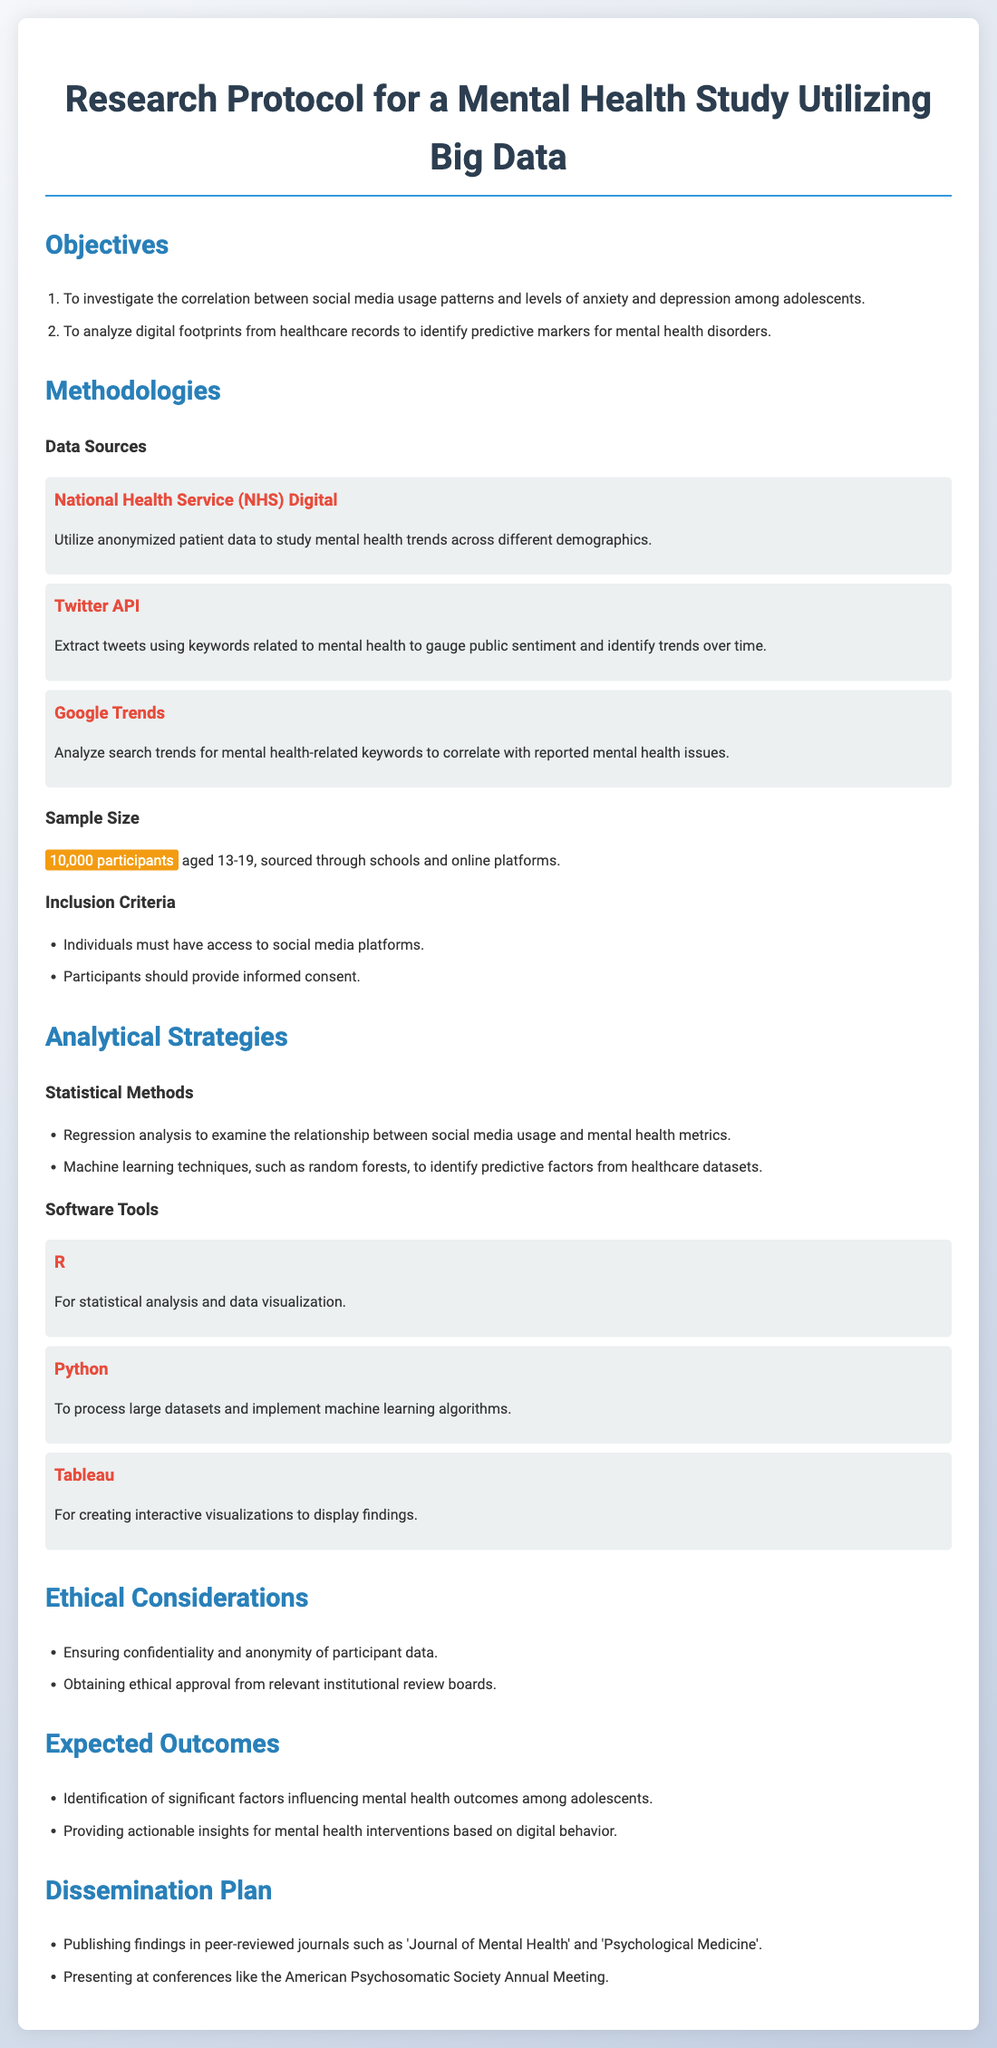What are the study populations? The study population includes individuals aged 13-19 recruited through schools and online platforms.
Answer: 10,000 participants What is the primary objective of the study? The primary objective is to investigate the correlation between social media usage patterns and levels of anxiety and depression.
Answer: Correlation between social media usage and mental health Which data source is used to analyze search trends for mental health-related keywords? The data source used for analyzing search trends is Google Trends.
Answer: Google Trends What statistical method is mentioned for examining the relationship between social media usage and mental health metrics? The statistical method mentioned is regression analysis.
Answer: Regression analysis How many inclusion criteria are specified in the document? There are two inclusion criteria specified for participant selection in the study.
Answer: 2 Where will the findings be published? The findings will be published in peer-reviewed journals such as 'Journal of Mental Health'.
Answer: Journal of Mental Health Which software tool is mentioned for creating interactive visualizations? The software tool mentioned for creating interactive visualizations is Tableau.
Answer: Tableau What is required to ensure the confidentiality of participant data? Confidentiality of participant data is ensured through data anonymization practices.
Answer: Data anonymization What is the sample size for this study? The sample size for the study is stated to be 10,000 participants.
Answer: 10,000 participants 